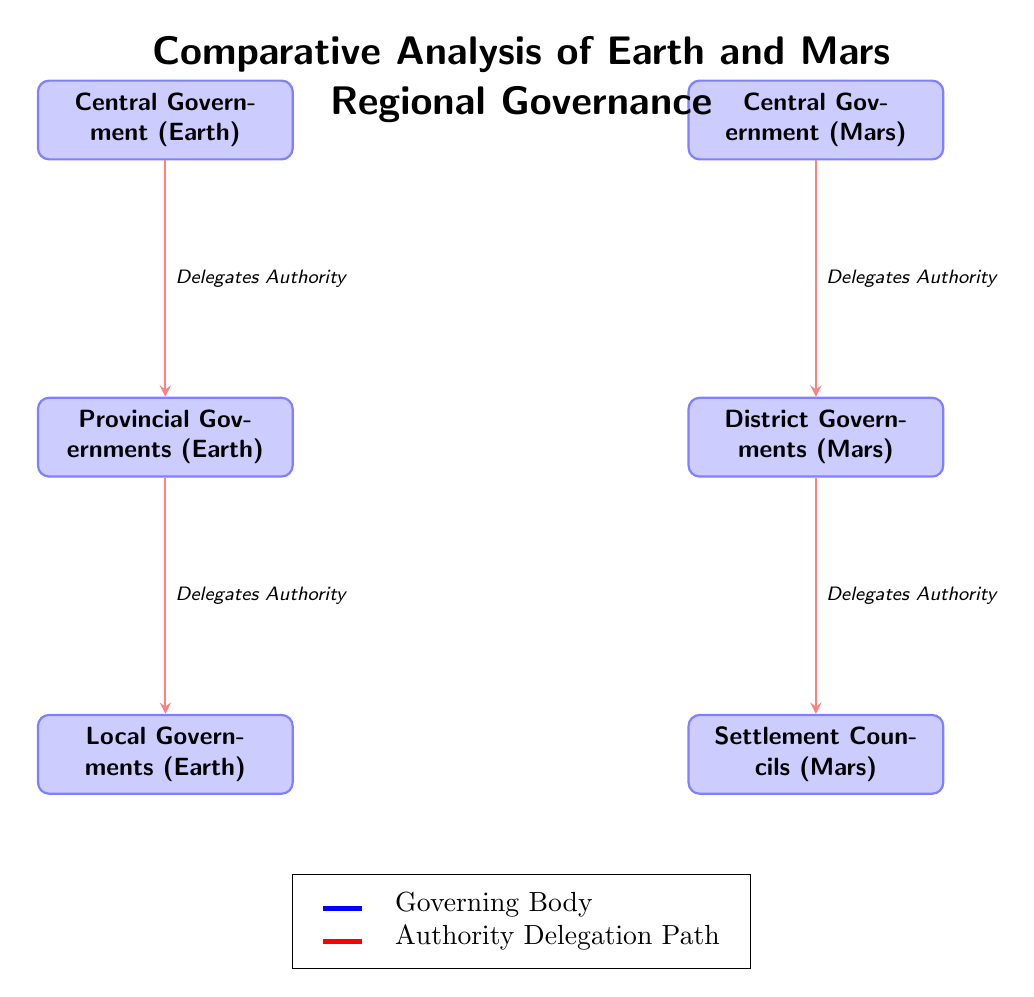What is the top node for Earth governance? The top node for Earth governance is the Central Government (Earth). This can be identified as the node positioned at the top of the Earth governance section of the diagram.
Answer: Central Government (Earth) How many levels of governance are depicted for Mars? The diagram shows three levels of governance for Mars: the Central Government, District Governments, and Settlement Councils. Each of these is represented as a separate node in the Mars section.
Answer: 3 What type of governance comes directly below the Central Government on Earth? The type of governance that comes directly below the Central Government on Earth is the Provincial Governments (Earth). This is determined by looking at the connection between the top Earth node and the one immediately below it.
Answer: Provincial Governments (Earth) What is the relationship between the Central Government and the District Governments on Mars? The relationship between the Central Government and the District Governments on Mars is that the Central Government delegates authority to the District Governments. This is indicated by the arrow labeled "Delegates Authority" from the Central Government to the District Governments.
Answer: Delegates Authority Which governance structure represents the lowest level for Mars? The governance structure that represents the lowest level for Mars is the Settlement Councils (Mars). This can be seen as it is the bottommost node in the Mars governance section of the diagram.
Answer: Settlement Councils (Mars) How many edges are in the Earth governance section? The Earth governance section has two edges. These edges represent authority delegation paths between the Central Government, Provincial Governments, and Local Governments.
Answer: 2 What color represents the governing bodies in the diagram? The governing bodies in the diagram are represented by the color blue. This can be easily identified as the fill color of the nodes labeled as government structures.
Answer: blue What is one way the structures of governance differ between Earth and Mars? One way the structures of governance differ is the terminology used; Earth uses Provincial and Local Governments, whereas Mars uses District Governments and Settlement Councils. This difference can be noted by comparing the names of the respective nodes for each planet.
Answer: Terminology differences What does the legend indicate about the red arrows in the diagram? The legend indicates that the red arrows represent the Authority Delegation Path. This is explicitly stated in the explanation of the legend, linking the color to its meaning in the context of the diagram.
Answer: Authority Delegation Path 